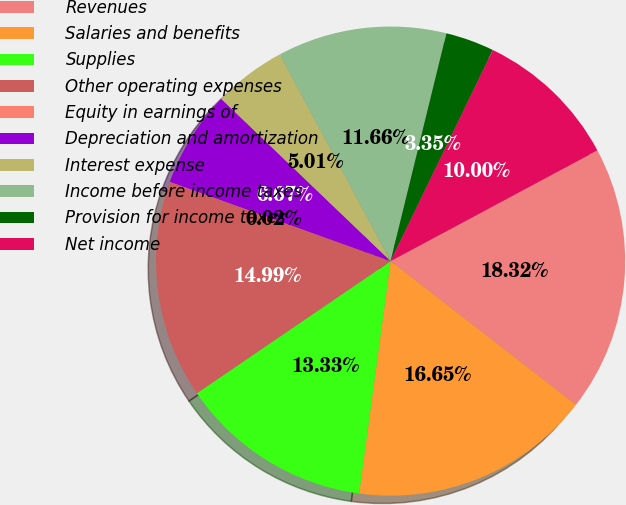Convert chart to OTSL. <chart><loc_0><loc_0><loc_500><loc_500><pie_chart><fcel>Revenues<fcel>Salaries and benefits<fcel>Supplies<fcel>Other operating expenses<fcel>Equity in earnings of<fcel>Depreciation and amortization<fcel>Interest expense<fcel>Income before income taxes<fcel>Provision for income taxes<fcel>Net income<nl><fcel>18.32%<fcel>16.65%<fcel>13.33%<fcel>14.99%<fcel>0.02%<fcel>6.67%<fcel>5.01%<fcel>11.66%<fcel>3.35%<fcel>10.0%<nl></chart> 